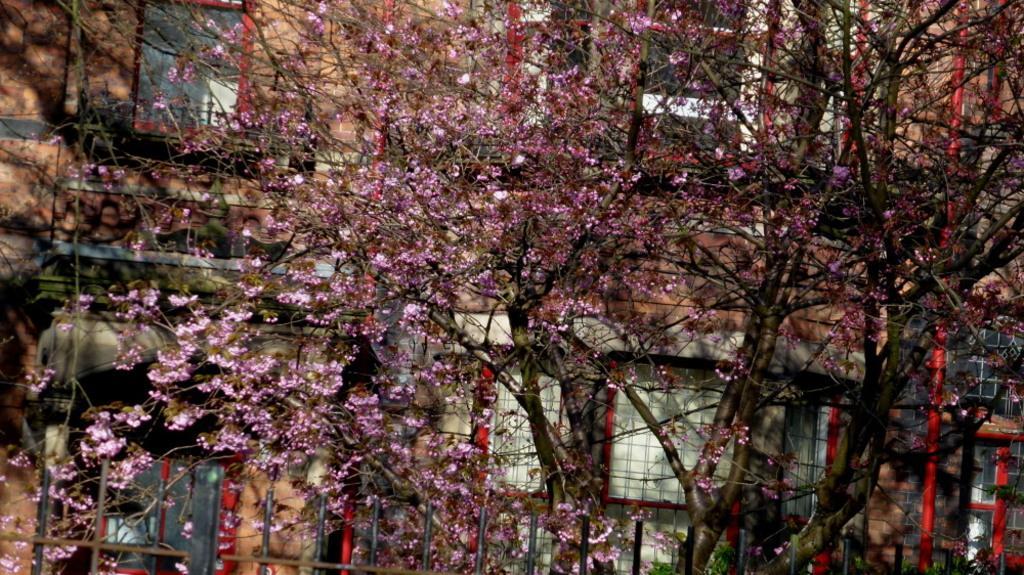Can you describe this image briefly? This picture is taken from the outside of the building. In this image, in the middle, we can see a tree with flowers which are in pink in color. In the background, we can see a building, glass window. 